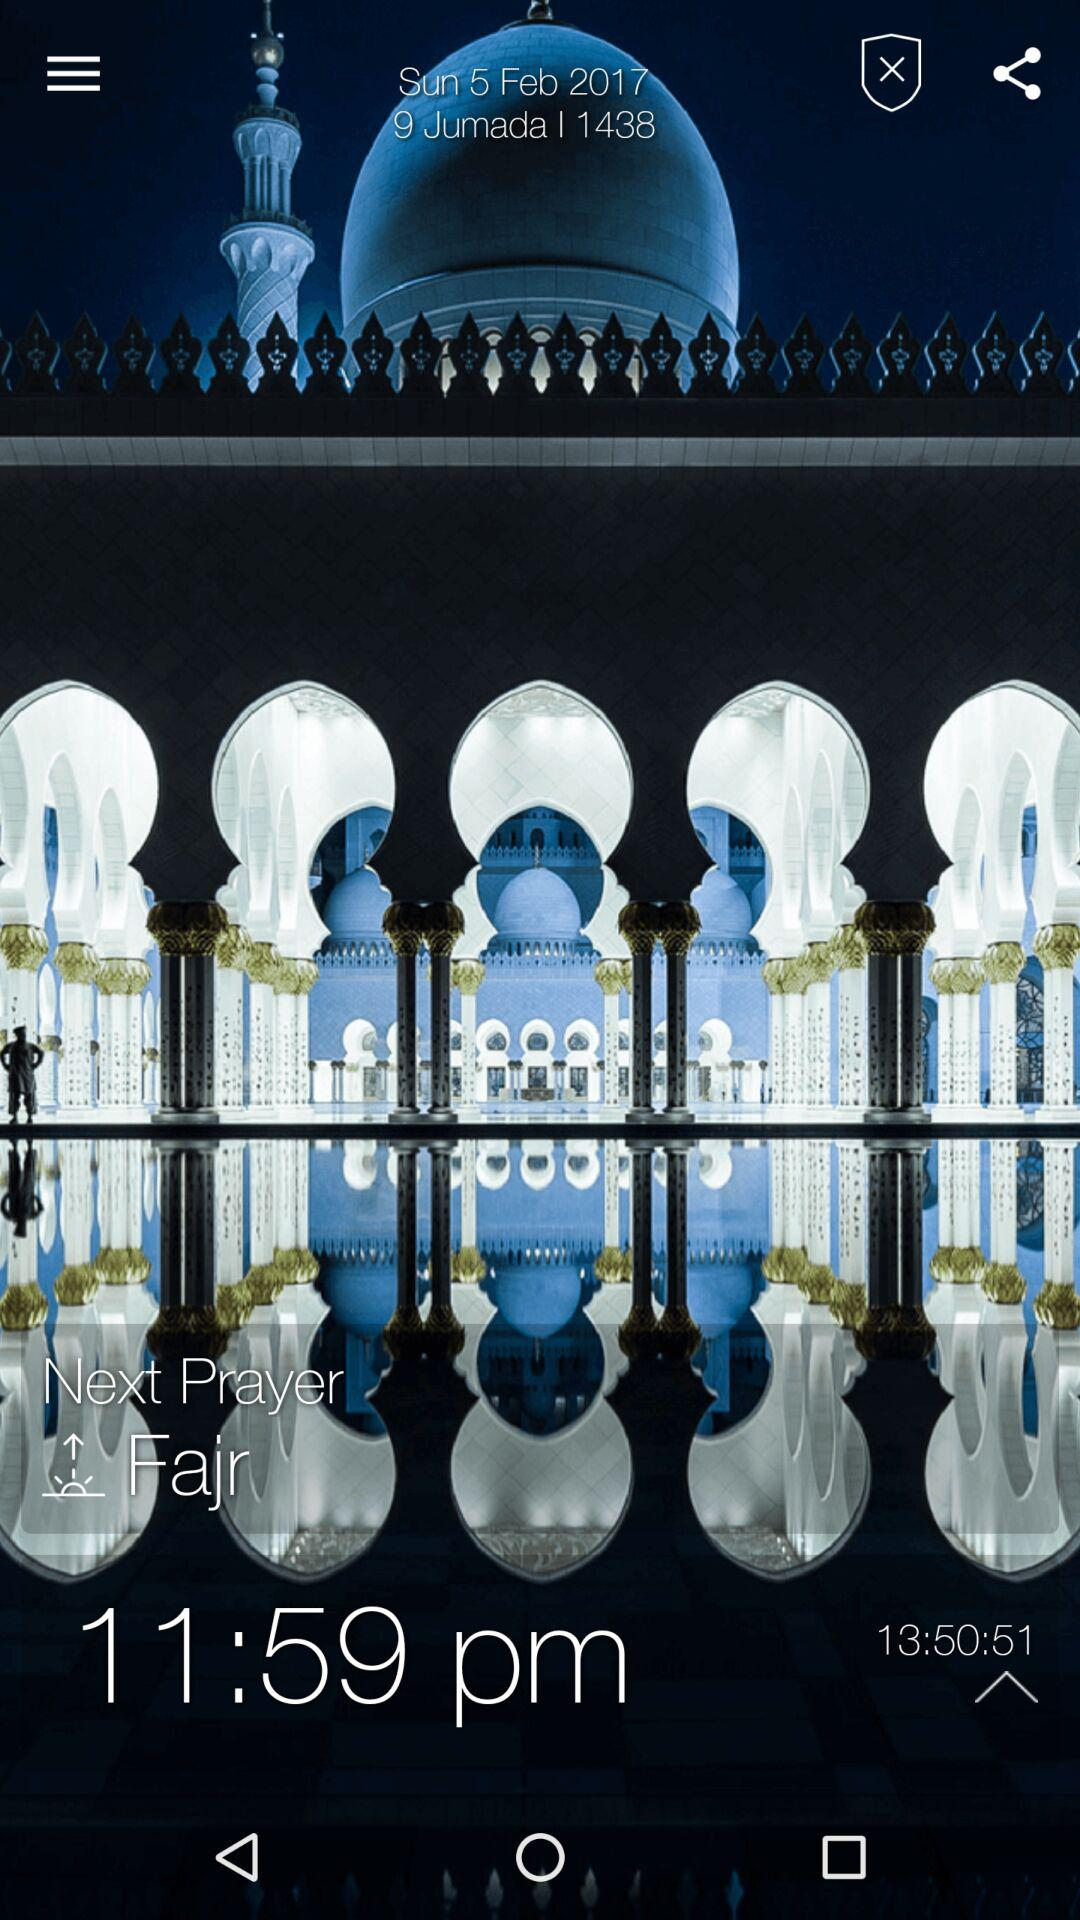Which is the next prayer? The next prayer is "Fajr". 